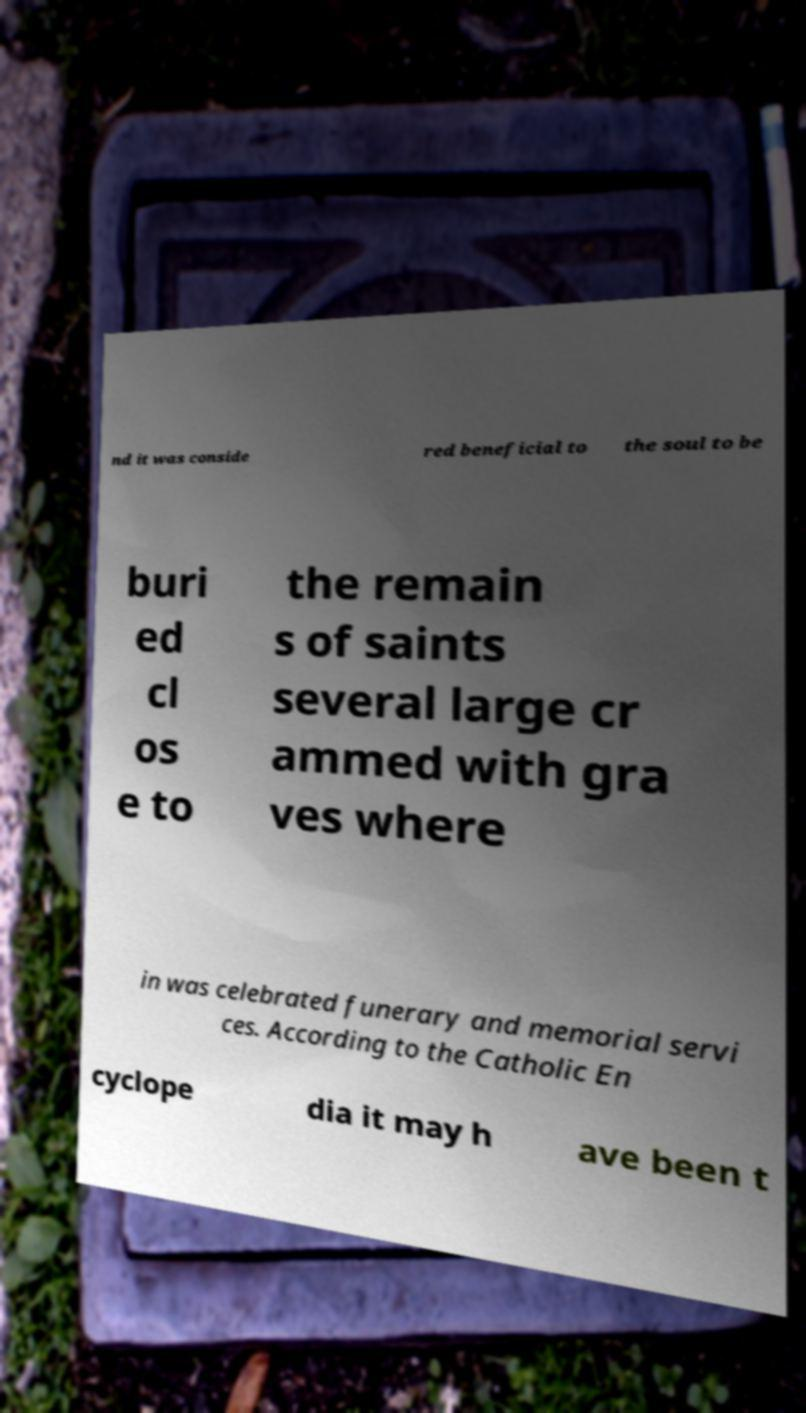I need the written content from this picture converted into text. Can you do that? nd it was conside red beneficial to the soul to be buri ed cl os e to the remain s of saints several large cr ammed with gra ves where in was celebrated funerary and memorial servi ces. According to the Catholic En cyclope dia it may h ave been t 